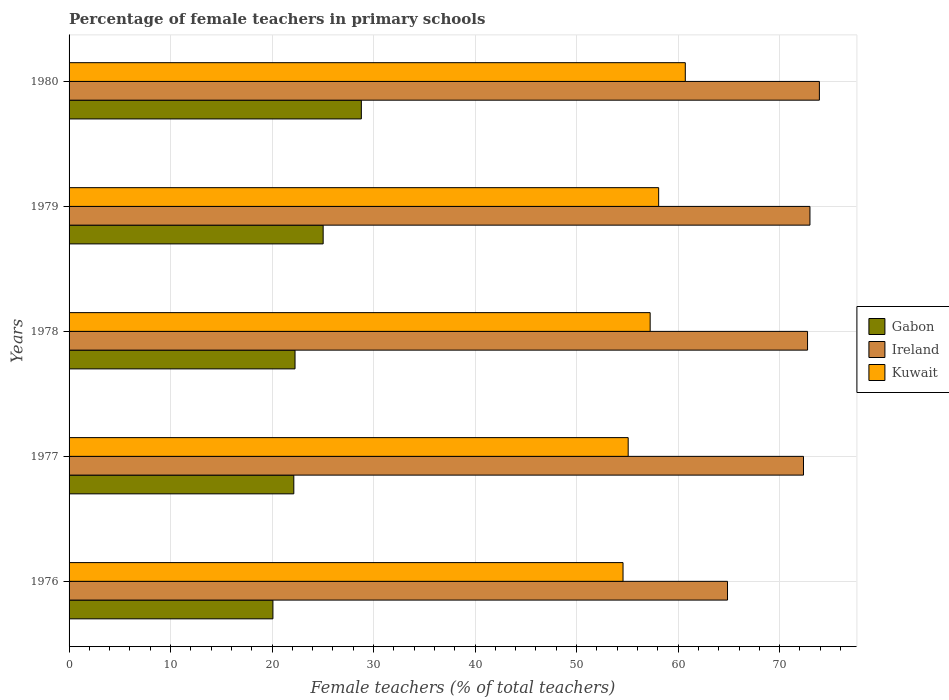How many bars are there on the 1st tick from the top?
Offer a very short reply. 3. What is the label of the 5th group of bars from the top?
Your response must be concise. 1976. In how many cases, is the number of bars for a given year not equal to the number of legend labels?
Ensure brevity in your answer.  0. What is the percentage of female teachers in Ireland in 1977?
Make the answer very short. 72.35. Across all years, what is the maximum percentage of female teachers in Gabon?
Ensure brevity in your answer.  28.79. Across all years, what is the minimum percentage of female teachers in Gabon?
Offer a very short reply. 20.08. In which year was the percentage of female teachers in Gabon minimum?
Provide a succinct answer. 1976. What is the total percentage of female teachers in Ireland in the graph?
Make the answer very short. 356.89. What is the difference between the percentage of female teachers in Ireland in 1977 and that in 1978?
Your answer should be very brief. -0.4. What is the difference between the percentage of female teachers in Ireland in 1979 and the percentage of female teachers in Kuwait in 1978?
Your response must be concise. 15.74. What is the average percentage of female teachers in Kuwait per year?
Keep it short and to the point. 57.14. In the year 1978, what is the difference between the percentage of female teachers in Gabon and percentage of female teachers in Ireland?
Offer a very short reply. -50.49. In how many years, is the percentage of female teachers in Kuwait greater than 24 %?
Your response must be concise. 5. What is the ratio of the percentage of female teachers in Kuwait in 1976 to that in 1980?
Provide a short and direct response. 0.9. Is the percentage of female teachers in Kuwait in 1976 less than that in 1977?
Offer a very short reply. Yes. Is the difference between the percentage of female teachers in Gabon in 1976 and 1979 greater than the difference between the percentage of female teachers in Ireland in 1976 and 1979?
Your answer should be very brief. Yes. What is the difference between the highest and the second highest percentage of female teachers in Kuwait?
Your answer should be very brief. 2.62. What is the difference between the highest and the lowest percentage of female teachers in Gabon?
Provide a succinct answer. 8.71. Is the sum of the percentage of female teachers in Ireland in 1978 and 1980 greater than the maximum percentage of female teachers in Kuwait across all years?
Your response must be concise. Yes. What does the 3rd bar from the top in 1977 represents?
Your answer should be compact. Gabon. What does the 3rd bar from the bottom in 1979 represents?
Offer a very short reply. Kuwait. Is it the case that in every year, the sum of the percentage of female teachers in Kuwait and percentage of female teachers in Ireland is greater than the percentage of female teachers in Gabon?
Your answer should be very brief. Yes. Are all the bars in the graph horizontal?
Give a very brief answer. Yes. Are the values on the major ticks of X-axis written in scientific E-notation?
Offer a very short reply. No. Does the graph contain any zero values?
Your answer should be compact. No. Does the graph contain grids?
Your answer should be compact. Yes. What is the title of the graph?
Provide a succinct answer. Percentage of female teachers in primary schools. What is the label or title of the X-axis?
Offer a terse response. Female teachers (% of total teachers). What is the label or title of the Y-axis?
Make the answer very short. Years. What is the Female teachers (% of total teachers) of Gabon in 1976?
Your answer should be very brief. 20.08. What is the Female teachers (% of total teachers) of Ireland in 1976?
Your answer should be compact. 64.87. What is the Female teachers (% of total teachers) in Kuwait in 1976?
Give a very brief answer. 54.58. What is the Female teachers (% of total teachers) in Gabon in 1977?
Make the answer very short. 22.14. What is the Female teachers (% of total teachers) in Ireland in 1977?
Your answer should be very brief. 72.35. What is the Female teachers (% of total teachers) in Kuwait in 1977?
Provide a short and direct response. 55.08. What is the Female teachers (% of total teachers) of Gabon in 1978?
Provide a succinct answer. 22.26. What is the Female teachers (% of total teachers) of Ireland in 1978?
Keep it short and to the point. 72.75. What is the Female teachers (% of total teachers) in Kuwait in 1978?
Provide a succinct answer. 57.25. What is the Female teachers (% of total teachers) in Gabon in 1979?
Ensure brevity in your answer.  25.03. What is the Female teachers (% of total teachers) in Ireland in 1979?
Keep it short and to the point. 72.99. What is the Female teachers (% of total teachers) in Kuwait in 1979?
Provide a short and direct response. 58.08. What is the Female teachers (% of total teachers) in Gabon in 1980?
Offer a terse response. 28.79. What is the Female teachers (% of total teachers) in Ireland in 1980?
Provide a short and direct response. 73.92. What is the Female teachers (% of total teachers) in Kuwait in 1980?
Give a very brief answer. 60.71. Across all years, what is the maximum Female teachers (% of total teachers) in Gabon?
Provide a short and direct response. 28.79. Across all years, what is the maximum Female teachers (% of total teachers) in Ireland?
Your answer should be compact. 73.92. Across all years, what is the maximum Female teachers (% of total teachers) in Kuwait?
Your response must be concise. 60.71. Across all years, what is the minimum Female teachers (% of total teachers) of Gabon?
Provide a succinct answer. 20.08. Across all years, what is the minimum Female teachers (% of total teachers) of Ireland?
Provide a short and direct response. 64.87. Across all years, what is the minimum Female teachers (% of total teachers) in Kuwait?
Your response must be concise. 54.58. What is the total Female teachers (% of total teachers) of Gabon in the graph?
Your response must be concise. 118.31. What is the total Female teachers (% of total teachers) in Ireland in the graph?
Your response must be concise. 356.89. What is the total Female teachers (% of total teachers) of Kuwait in the graph?
Offer a terse response. 285.7. What is the difference between the Female teachers (% of total teachers) in Gabon in 1976 and that in 1977?
Your response must be concise. -2.06. What is the difference between the Female teachers (% of total teachers) of Ireland in 1976 and that in 1977?
Offer a very short reply. -7.48. What is the difference between the Female teachers (% of total teachers) in Kuwait in 1976 and that in 1977?
Your answer should be very brief. -0.51. What is the difference between the Female teachers (% of total teachers) in Gabon in 1976 and that in 1978?
Provide a short and direct response. -2.18. What is the difference between the Female teachers (% of total teachers) of Ireland in 1976 and that in 1978?
Provide a succinct answer. -7.88. What is the difference between the Female teachers (% of total teachers) of Kuwait in 1976 and that in 1978?
Provide a succinct answer. -2.67. What is the difference between the Female teachers (% of total teachers) of Gabon in 1976 and that in 1979?
Ensure brevity in your answer.  -4.95. What is the difference between the Female teachers (% of total teachers) of Ireland in 1976 and that in 1979?
Offer a terse response. -8.12. What is the difference between the Female teachers (% of total teachers) of Kuwait in 1976 and that in 1979?
Your response must be concise. -3.51. What is the difference between the Female teachers (% of total teachers) of Gabon in 1976 and that in 1980?
Your answer should be very brief. -8.71. What is the difference between the Female teachers (% of total teachers) in Ireland in 1976 and that in 1980?
Your answer should be very brief. -9.05. What is the difference between the Female teachers (% of total teachers) of Kuwait in 1976 and that in 1980?
Offer a very short reply. -6.13. What is the difference between the Female teachers (% of total teachers) in Gabon in 1977 and that in 1978?
Provide a short and direct response. -0.12. What is the difference between the Female teachers (% of total teachers) in Ireland in 1977 and that in 1978?
Ensure brevity in your answer.  -0.4. What is the difference between the Female teachers (% of total teachers) in Kuwait in 1977 and that in 1978?
Provide a short and direct response. -2.16. What is the difference between the Female teachers (% of total teachers) in Gabon in 1977 and that in 1979?
Provide a succinct answer. -2.89. What is the difference between the Female teachers (% of total teachers) of Ireland in 1977 and that in 1979?
Keep it short and to the point. -0.64. What is the difference between the Female teachers (% of total teachers) in Kuwait in 1977 and that in 1979?
Your answer should be very brief. -3. What is the difference between the Female teachers (% of total teachers) of Gabon in 1977 and that in 1980?
Your response must be concise. -6.65. What is the difference between the Female teachers (% of total teachers) in Ireland in 1977 and that in 1980?
Keep it short and to the point. -1.57. What is the difference between the Female teachers (% of total teachers) in Kuwait in 1977 and that in 1980?
Your answer should be compact. -5.63. What is the difference between the Female teachers (% of total teachers) of Gabon in 1978 and that in 1979?
Offer a terse response. -2.77. What is the difference between the Female teachers (% of total teachers) in Ireland in 1978 and that in 1979?
Provide a succinct answer. -0.24. What is the difference between the Female teachers (% of total teachers) of Kuwait in 1978 and that in 1979?
Provide a succinct answer. -0.84. What is the difference between the Female teachers (% of total teachers) of Gabon in 1978 and that in 1980?
Make the answer very short. -6.53. What is the difference between the Female teachers (% of total teachers) in Ireland in 1978 and that in 1980?
Give a very brief answer. -1.17. What is the difference between the Female teachers (% of total teachers) in Kuwait in 1978 and that in 1980?
Give a very brief answer. -3.46. What is the difference between the Female teachers (% of total teachers) in Gabon in 1979 and that in 1980?
Your answer should be very brief. -3.76. What is the difference between the Female teachers (% of total teachers) of Ireland in 1979 and that in 1980?
Provide a short and direct response. -0.93. What is the difference between the Female teachers (% of total teachers) in Kuwait in 1979 and that in 1980?
Keep it short and to the point. -2.62. What is the difference between the Female teachers (% of total teachers) in Gabon in 1976 and the Female teachers (% of total teachers) in Ireland in 1977?
Provide a succinct answer. -52.27. What is the difference between the Female teachers (% of total teachers) in Gabon in 1976 and the Female teachers (% of total teachers) in Kuwait in 1977?
Give a very brief answer. -35. What is the difference between the Female teachers (% of total teachers) in Ireland in 1976 and the Female teachers (% of total teachers) in Kuwait in 1977?
Provide a short and direct response. 9.79. What is the difference between the Female teachers (% of total teachers) in Gabon in 1976 and the Female teachers (% of total teachers) in Ireland in 1978?
Give a very brief answer. -52.67. What is the difference between the Female teachers (% of total teachers) of Gabon in 1976 and the Female teachers (% of total teachers) of Kuwait in 1978?
Provide a short and direct response. -37.16. What is the difference between the Female teachers (% of total teachers) of Ireland in 1976 and the Female teachers (% of total teachers) of Kuwait in 1978?
Provide a short and direct response. 7.62. What is the difference between the Female teachers (% of total teachers) of Gabon in 1976 and the Female teachers (% of total teachers) of Ireland in 1979?
Your answer should be very brief. -52.91. What is the difference between the Female teachers (% of total teachers) of Gabon in 1976 and the Female teachers (% of total teachers) of Kuwait in 1979?
Provide a short and direct response. -38. What is the difference between the Female teachers (% of total teachers) in Ireland in 1976 and the Female teachers (% of total teachers) in Kuwait in 1979?
Ensure brevity in your answer.  6.79. What is the difference between the Female teachers (% of total teachers) in Gabon in 1976 and the Female teachers (% of total teachers) in Ireland in 1980?
Provide a short and direct response. -53.84. What is the difference between the Female teachers (% of total teachers) in Gabon in 1976 and the Female teachers (% of total teachers) in Kuwait in 1980?
Your response must be concise. -40.63. What is the difference between the Female teachers (% of total teachers) of Ireland in 1976 and the Female teachers (% of total teachers) of Kuwait in 1980?
Your response must be concise. 4.16. What is the difference between the Female teachers (% of total teachers) in Gabon in 1977 and the Female teachers (% of total teachers) in Ireland in 1978?
Offer a very short reply. -50.61. What is the difference between the Female teachers (% of total teachers) in Gabon in 1977 and the Female teachers (% of total teachers) in Kuwait in 1978?
Offer a terse response. -35.11. What is the difference between the Female teachers (% of total teachers) in Ireland in 1977 and the Female teachers (% of total teachers) in Kuwait in 1978?
Offer a very short reply. 15.11. What is the difference between the Female teachers (% of total teachers) of Gabon in 1977 and the Female teachers (% of total teachers) of Ireland in 1979?
Offer a very short reply. -50.85. What is the difference between the Female teachers (% of total teachers) of Gabon in 1977 and the Female teachers (% of total teachers) of Kuwait in 1979?
Give a very brief answer. -35.94. What is the difference between the Female teachers (% of total teachers) in Ireland in 1977 and the Female teachers (% of total teachers) in Kuwait in 1979?
Provide a short and direct response. 14.27. What is the difference between the Female teachers (% of total teachers) of Gabon in 1977 and the Female teachers (% of total teachers) of Ireland in 1980?
Your answer should be compact. -51.78. What is the difference between the Female teachers (% of total teachers) of Gabon in 1977 and the Female teachers (% of total teachers) of Kuwait in 1980?
Give a very brief answer. -38.57. What is the difference between the Female teachers (% of total teachers) in Ireland in 1977 and the Female teachers (% of total teachers) in Kuwait in 1980?
Your answer should be compact. 11.64. What is the difference between the Female teachers (% of total teachers) in Gabon in 1978 and the Female teachers (% of total teachers) in Ireland in 1979?
Offer a very short reply. -50.73. What is the difference between the Female teachers (% of total teachers) of Gabon in 1978 and the Female teachers (% of total teachers) of Kuwait in 1979?
Keep it short and to the point. -35.82. What is the difference between the Female teachers (% of total teachers) of Ireland in 1978 and the Female teachers (% of total teachers) of Kuwait in 1979?
Provide a short and direct response. 14.67. What is the difference between the Female teachers (% of total teachers) in Gabon in 1978 and the Female teachers (% of total teachers) in Ireland in 1980?
Offer a very short reply. -51.66. What is the difference between the Female teachers (% of total teachers) of Gabon in 1978 and the Female teachers (% of total teachers) of Kuwait in 1980?
Make the answer very short. -38.45. What is the difference between the Female teachers (% of total teachers) in Ireland in 1978 and the Female teachers (% of total teachers) in Kuwait in 1980?
Provide a succinct answer. 12.04. What is the difference between the Female teachers (% of total teachers) in Gabon in 1979 and the Female teachers (% of total teachers) in Ireland in 1980?
Your answer should be very brief. -48.89. What is the difference between the Female teachers (% of total teachers) in Gabon in 1979 and the Female teachers (% of total teachers) in Kuwait in 1980?
Your answer should be very brief. -35.68. What is the difference between the Female teachers (% of total teachers) in Ireland in 1979 and the Female teachers (% of total teachers) in Kuwait in 1980?
Offer a terse response. 12.28. What is the average Female teachers (% of total teachers) in Gabon per year?
Give a very brief answer. 23.66. What is the average Female teachers (% of total teachers) of Ireland per year?
Offer a very short reply. 71.38. What is the average Female teachers (% of total teachers) of Kuwait per year?
Make the answer very short. 57.14. In the year 1976, what is the difference between the Female teachers (% of total teachers) in Gabon and Female teachers (% of total teachers) in Ireland?
Offer a terse response. -44.79. In the year 1976, what is the difference between the Female teachers (% of total teachers) in Gabon and Female teachers (% of total teachers) in Kuwait?
Give a very brief answer. -34.49. In the year 1976, what is the difference between the Female teachers (% of total teachers) in Ireland and Female teachers (% of total teachers) in Kuwait?
Give a very brief answer. 10.29. In the year 1977, what is the difference between the Female teachers (% of total teachers) in Gabon and Female teachers (% of total teachers) in Ireland?
Keep it short and to the point. -50.21. In the year 1977, what is the difference between the Female teachers (% of total teachers) in Gabon and Female teachers (% of total teachers) in Kuwait?
Ensure brevity in your answer.  -32.94. In the year 1977, what is the difference between the Female teachers (% of total teachers) in Ireland and Female teachers (% of total teachers) in Kuwait?
Provide a succinct answer. 17.27. In the year 1978, what is the difference between the Female teachers (% of total teachers) of Gabon and Female teachers (% of total teachers) of Ireland?
Your answer should be very brief. -50.49. In the year 1978, what is the difference between the Female teachers (% of total teachers) of Gabon and Female teachers (% of total teachers) of Kuwait?
Your answer should be very brief. -34.99. In the year 1978, what is the difference between the Female teachers (% of total teachers) of Ireland and Female teachers (% of total teachers) of Kuwait?
Make the answer very short. 15.51. In the year 1979, what is the difference between the Female teachers (% of total teachers) of Gabon and Female teachers (% of total teachers) of Ireland?
Give a very brief answer. -47.96. In the year 1979, what is the difference between the Female teachers (% of total teachers) in Gabon and Female teachers (% of total teachers) in Kuwait?
Your answer should be very brief. -33.05. In the year 1979, what is the difference between the Female teachers (% of total teachers) in Ireland and Female teachers (% of total teachers) in Kuwait?
Make the answer very short. 14.91. In the year 1980, what is the difference between the Female teachers (% of total teachers) in Gabon and Female teachers (% of total teachers) in Ireland?
Your answer should be compact. -45.13. In the year 1980, what is the difference between the Female teachers (% of total teachers) in Gabon and Female teachers (% of total teachers) in Kuwait?
Keep it short and to the point. -31.92. In the year 1980, what is the difference between the Female teachers (% of total teachers) of Ireland and Female teachers (% of total teachers) of Kuwait?
Provide a short and direct response. 13.21. What is the ratio of the Female teachers (% of total teachers) in Gabon in 1976 to that in 1977?
Your answer should be very brief. 0.91. What is the ratio of the Female teachers (% of total teachers) of Ireland in 1976 to that in 1977?
Make the answer very short. 0.9. What is the ratio of the Female teachers (% of total teachers) of Gabon in 1976 to that in 1978?
Make the answer very short. 0.9. What is the ratio of the Female teachers (% of total teachers) of Ireland in 1976 to that in 1978?
Keep it short and to the point. 0.89. What is the ratio of the Female teachers (% of total teachers) of Kuwait in 1976 to that in 1978?
Give a very brief answer. 0.95. What is the ratio of the Female teachers (% of total teachers) in Gabon in 1976 to that in 1979?
Provide a short and direct response. 0.8. What is the ratio of the Female teachers (% of total teachers) of Ireland in 1976 to that in 1979?
Keep it short and to the point. 0.89. What is the ratio of the Female teachers (% of total teachers) in Kuwait in 1976 to that in 1979?
Offer a very short reply. 0.94. What is the ratio of the Female teachers (% of total teachers) of Gabon in 1976 to that in 1980?
Your response must be concise. 0.7. What is the ratio of the Female teachers (% of total teachers) of Ireland in 1976 to that in 1980?
Ensure brevity in your answer.  0.88. What is the ratio of the Female teachers (% of total teachers) of Kuwait in 1976 to that in 1980?
Provide a short and direct response. 0.9. What is the ratio of the Female teachers (% of total teachers) of Ireland in 1977 to that in 1978?
Keep it short and to the point. 0.99. What is the ratio of the Female teachers (% of total teachers) in Kuwait in 1977 to that in 1978?
Give a very brief answer. 0.96. What is the ratio of the Female teachers (% of total teachers) in Gabon in 1977 to that in 1979?
Ensure brevity in your answer.  0.88. What is the ratio of the Female teachers (% of total teachers) in Ireland in 1977 to that in 1979?
Make the answer very short. 0.99. What is the ratio of the Female teachers (% of total teachers) of Kuwait in 1977 to that in 1979?
Give a very brief answer. 0.95. What is the ratio of the Female teachers (% of total teachers) of Gabon in 1977 to that in 1980?
Offer a terse response. 0.77. What is the ratio of the Female teachers (% of total teachers) in Ireland in 1977 to that in 1980?
Provide a succinct answer. 0.98. What is the ratio of the Female teachers (% of total teachers) in Kuwait in 1977 to that in 1980?
Offer a very short reply. 0.91. What is the ratio of the Female teachers (% of total teachers) of Gabon in 1978 to that in 1979?
Give a very brief answer. 0.89. What is the ratio of the Female teachers (% of total teachers) of Ireland in 1978 to that in 1979?
Keep it short and to the point. 1. What is the ratio of the Female teachers (% of total teachers) in Kuwait in 1978 to that in 1979?
Your answer should be very brief. 0.99. What is the ratio of the Female teachers (% of total teachers) in Gabon in 1978 to that in 1980?
Keep it short and to the point. 0.77. What is the ratio of the Female teachers (% of total teachers) of Ireland in 1978 to that in 1980?
Offer a terse response. 0.98. What is the ratio of the Female teachers (% of total teachers) in Kuwait in 1978 to that in 1980?
Provide a short and direct response. 0.94. What is the ratio of the Female teachers (% of total teachers) in Gabon in 1979 to that in 1980?
Ensure brevity in your answer.  0.87. What is the ratio of the Female teachers (% of total teachers) of Ireland in 1979 to that in 1980?
Your answer should be compact. 0.99. What is the ratio of the Female teachers (% of total teachers) of Kuwait in 1979 to that in 1980?
Keep it short and to the point. 0.96. What is the difference between the highest and the second highest Female teachers (% of total teachers) of Gabon?
Provide a succinct answer. 3.76. What is the difference between the highest and the second highest Female teachers (% of total teachers) in Ireland?
Provide a succinct answer. 0.93. What is the difference between the highest and the second highest Female teachers (% of total teachers) of Kuwait?
Keep it short and to the point. 2.62. What is the difference between the highest and the lowest Female teachers (% of total teachers) of Gabon?
Offer a very short reply. 8.71. What is the difference between the highest and the lowest Female teachers (% of total teachers) of Ireland?
Give a very brief answer. 9.05. What is the difference between the highest and the lowest Female teachers (% of total teachers) in Kuwait?
Offer a very short reply. 6.13. 